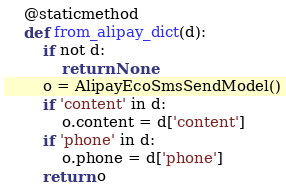<code> <loc_0><loc_0><loc_500><loc_500><_Python_>
    @staticmethod
    def from_alipay_dict(d):
        if not d:
            return None
        o = AlipayEcoSmsSendModel()
        if 'content' in d:
            o.content = d['content']
        if 'phone' in d:
            o.phone = d['phone']
        return o


</code> 